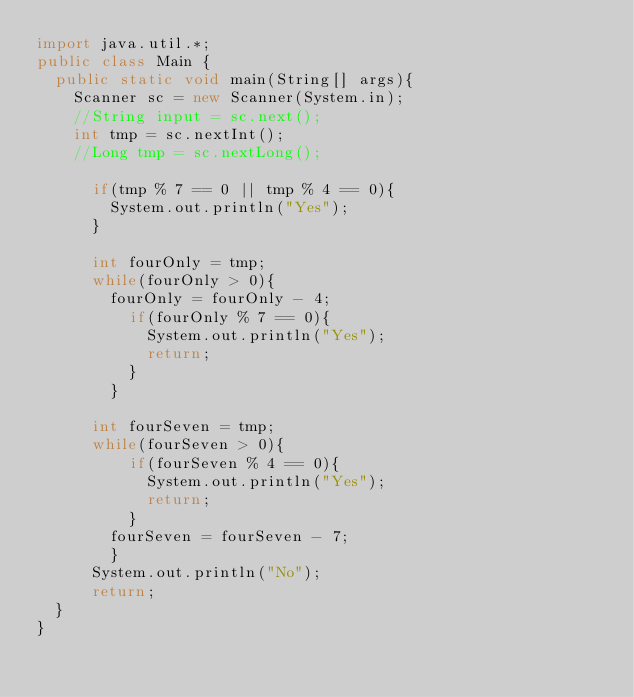Convert code to text. <code><loc_0><loc_0><loc_500><loc_500><_Java_>import java.util.*;
public class Main {
	public static void main(String[] args){
		Scanner sc = new Scanner(System.in);
		//String input = sc.next();
		int tmp = sc.nextInt();
		//Long tmp = sc.nextLong();
      	
      if(tmp % 7 == 0 || tmp % 4 == 0){
        System.out.println("Yes");
      }
      
      int fourOnly = tmp;
      while(fourOnly > 0){
        fourOnly = fourOnly - 4;
          if(fourOnly % 7 == 0){
            System.out.println("Yes");
            return;
          }
        }
      
      int fourSeven = tmp;      
      while(fourSeven > 0){
          if(fourSeven % 4 == 0){
            System.out.println("Yes");
            return;
          }
        fourSeven = fourSeven - 7;
        }
      System.out.println("No");
      return;
	}
}
</code> 